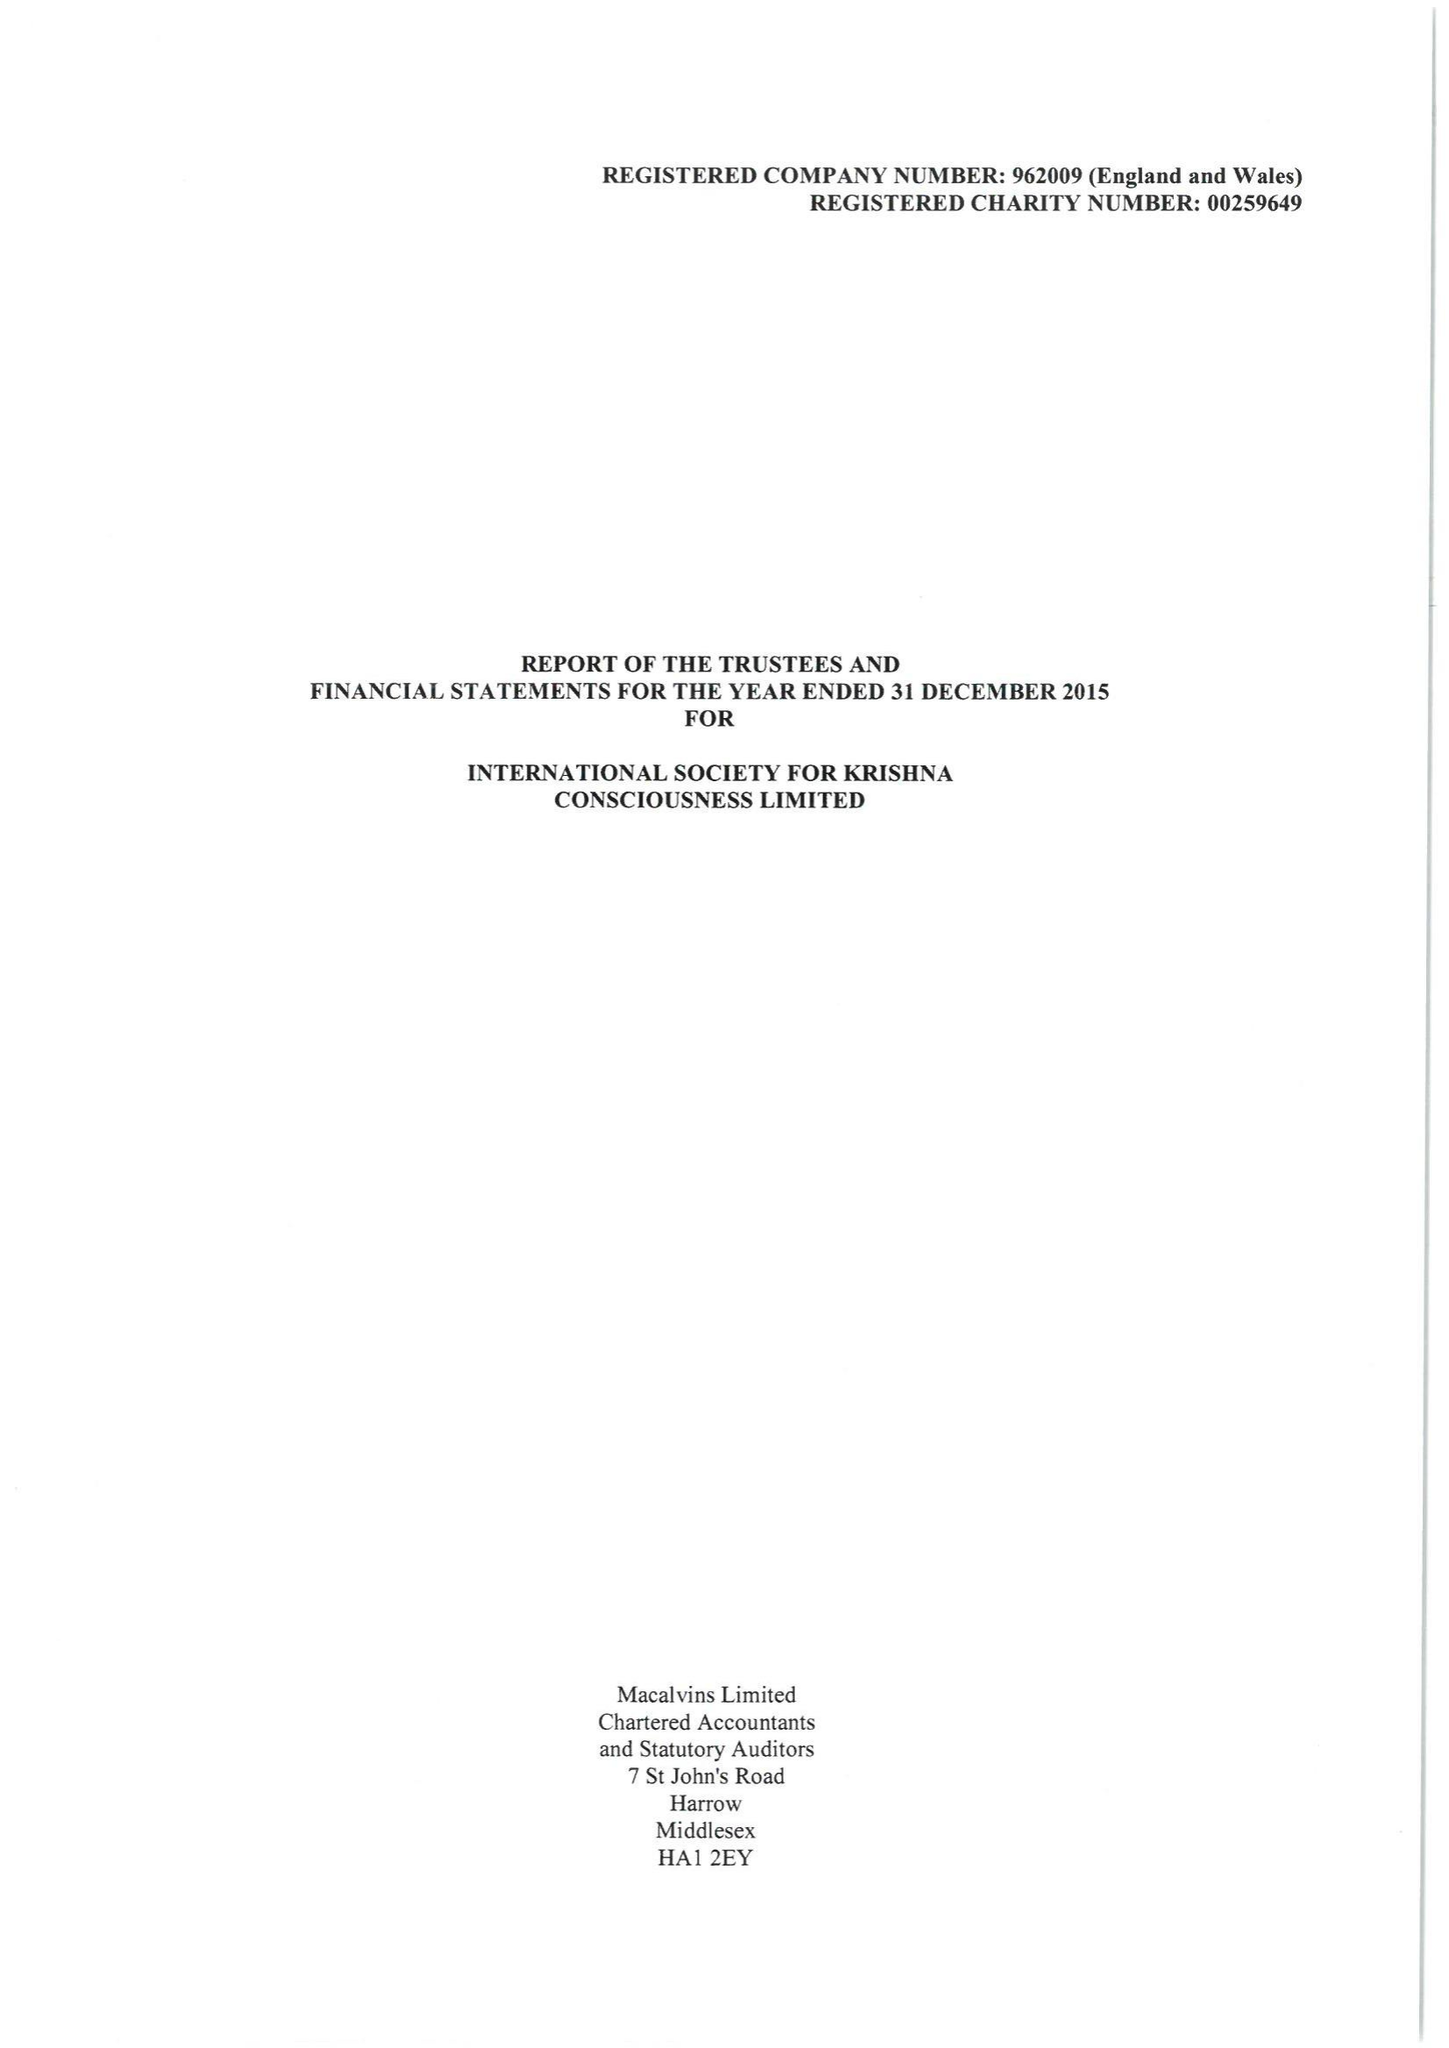What is the value for the spending_annually_in_british_pounds?
Answer the question using a single word or phrase. 6045197.00 